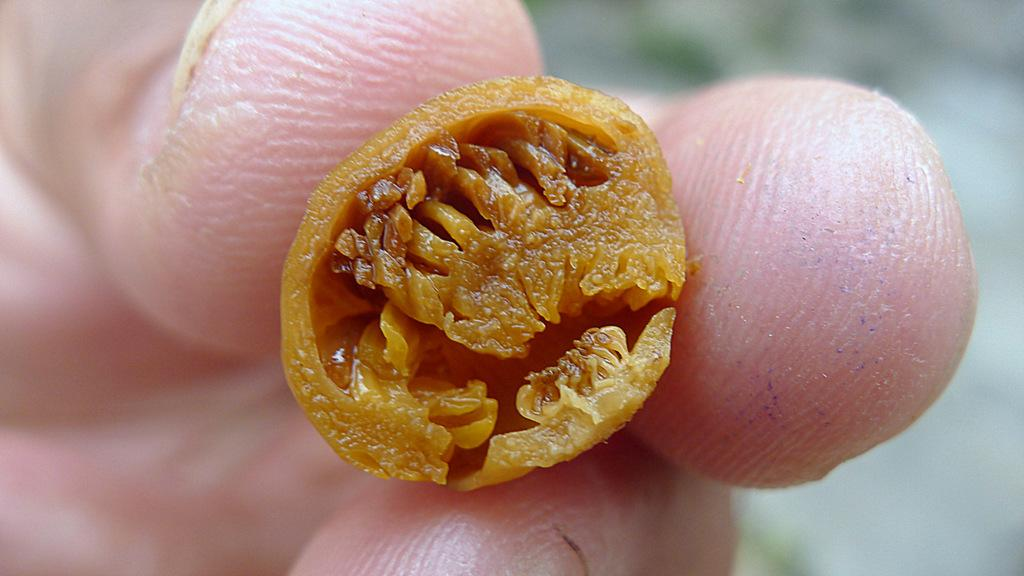What is present in the image? There is a person in the image. What is the person holding? The person is holding a brown object. Can you describe the background of the image? The background of the image is blurred. Are there any fairies visible in the image? No, there are no fairies present in the image. What type of road can be seen in the image? There is no road visible in the image. 